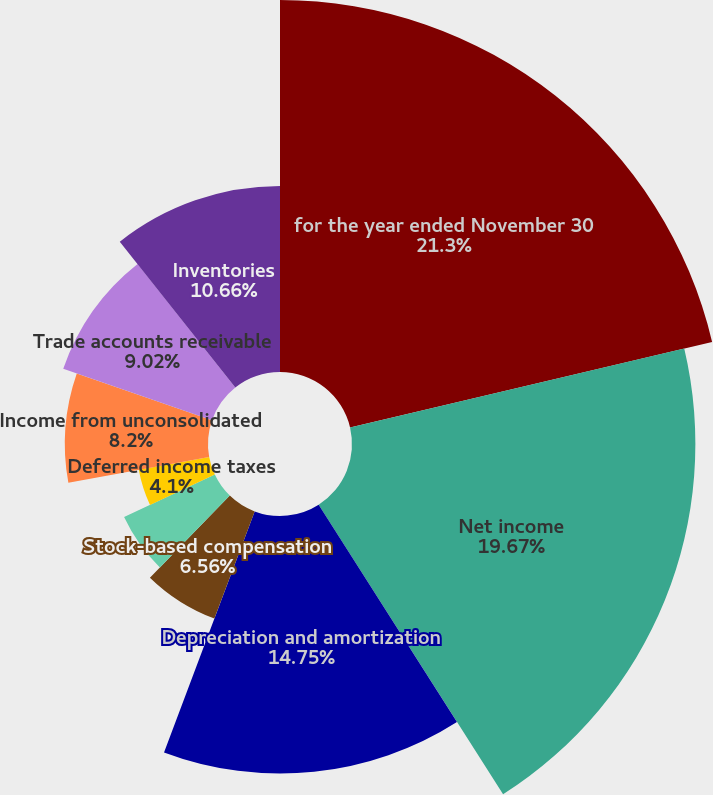Convert chart to OTSL. <chart><loc_0><loc_0><loc_500><loc_500><pie_chart><fcel>for the year ended November 30<fcel>Net income<fcel>Depreciation and amortization<fcel>Stock-based compensation<fcel>Special charges<fcel>Loss on sale of assets<fcel>Deferred income taxes<fcel>Income from unconsolidated<fcel>Trade accounts receivable<fcel>Inventories<nl><fcel>21.31%<fcel>19.67%<fcel>14.75%<fcel>6.56%<fcel>5.74%<fcel>0.0%<fcel>4.1%<fcel>8.2%<fcel>9.02%<fcel>10.66%<nl></chart> 